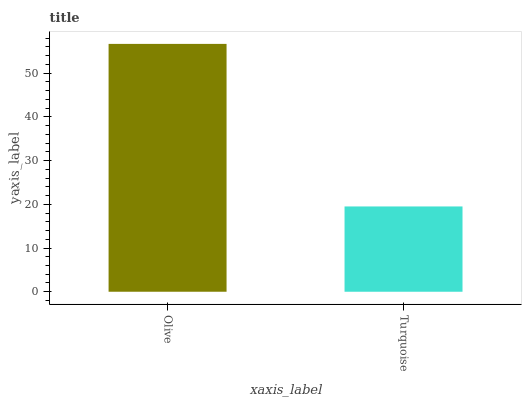Is Turquoise the maximum?
Answer yes or no. No. Is Olive greater than Turquoise?
Answer yes or no. Yes. Is Turquoise less than Olive?
Answer yes or no. Yes. Is Turquoise greater than Olive?
Answer yes or no. No. Is Olive less than Turquoise?
Answer yes or no. No. Is Olive the high median?
Answer yes or no. Yes. Is Turquoise the low median?
Answer yes or no. Yes. Is Turquoise the high median?
Answer yes or no. No. Is Olive the low median?
Answer yes or no. No. 